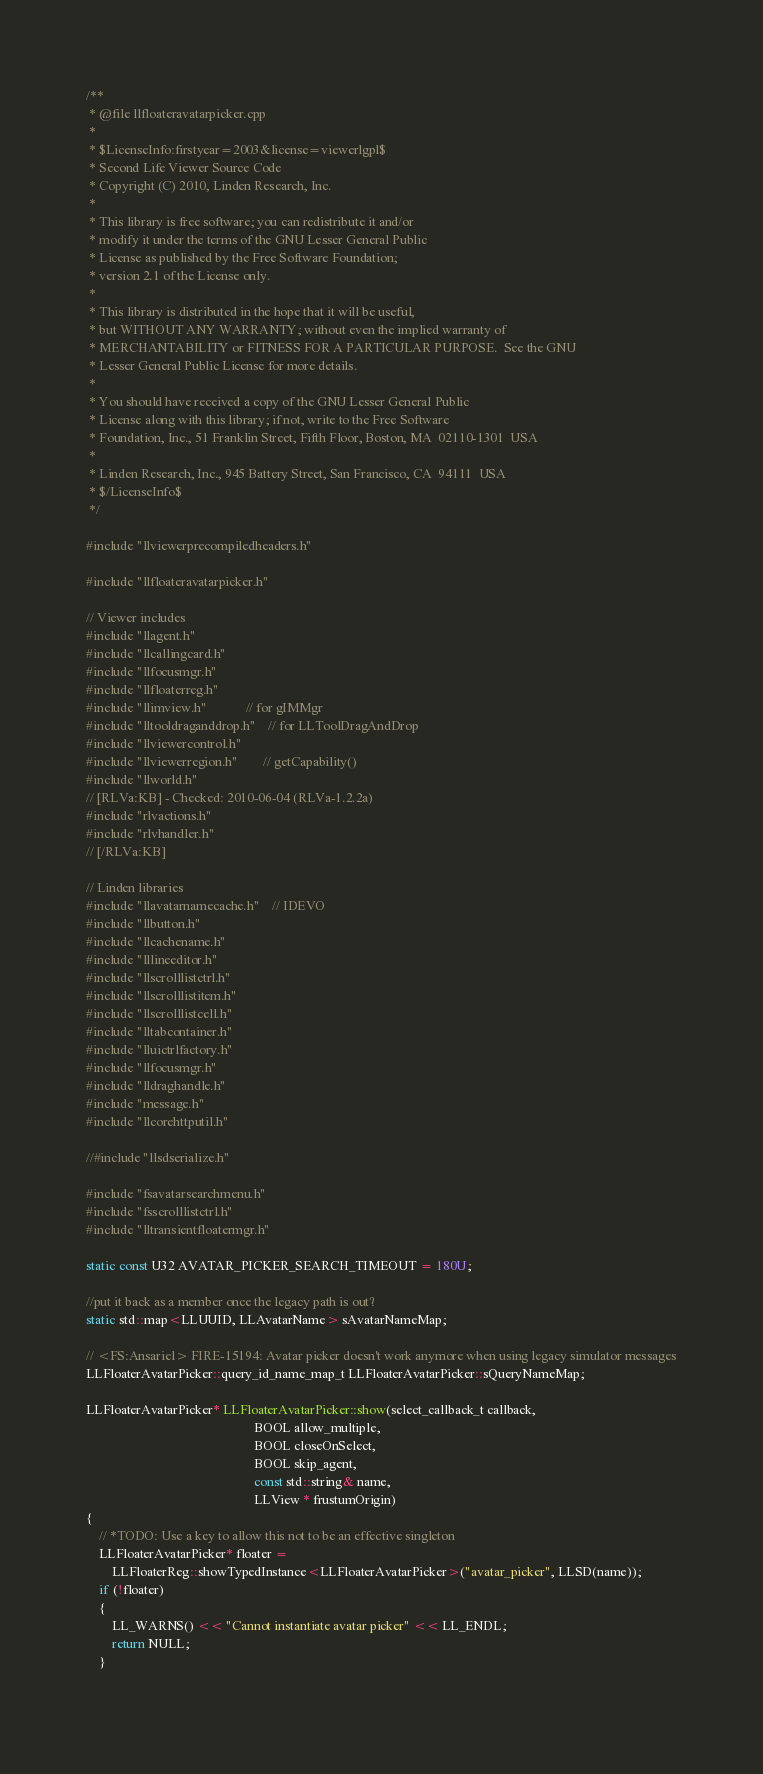Convert code to text. <code><loc_0><loc_0><loc_500><loc_500><_C++_>/** 
 * @file llfloateravatarpicker.cpp
 *
 * $LicenseInfo:firstyear=2003&license=viewerlgpl$
 * Second Life Viewer Source Code
 * Copyright (C) 2010, Linden Research, Inc.
 * 
 * This library is free software; you can redistribute it and/or
 * modify it under the terms of the GNU Lesser General Public
 * License as published by the Free Software Foundation;
 * version 2.1 of the License only.
 * 
 * This library is distributed in the hope that it will be useful,
 * but WITHOUT ANY WARRANTY; without even the implied warranty of
 * MERCHANTABILITY or FITNESS FOR A PARTICULAR PURPOSE.  See the GNU
 * Lesser General Public License for more details.
 * 
 * You should have received a copy of the GNU Lesser General Public
 * License along with this library; if not, write to the Free Software
 * Foundation, Inc., 51 Franklin Street, Fifth Floor, Boston, MA  02110-1301  USA
 * 
 * Linden Research, Inc., 945 Battery Street, San Francisco, CA  94111  USA
 * $/LicenseInfo$
 */

#include "llviewerprecompiledheaders.h"

#include "llfloateravatarpicker.h"

// Viewer includes
#include "llagent.h"
#include "llcallingcard.h"
#include "llfocusmgr.h"
#include "llfloaterreg.h"
#include "llimview.h"			// for gIMMgr
#include "lltooldraganddrop.h"	// for LLToolDragAndDrop
#include "llviewercontrol.h"
#include "llviewerregion.h"		// getCapability()
#include "llworld.h"
// [RLVa:KB] - Checked: 2010-06-04 (RLVa-1.2.2a)
#include "rlvactions.h"
#include "rlvhandler.h"
// [/RLVa:KB]

// Linden libraries
#include "llavatarnamecache.h"	// IDEVO
#include "llbutton.h"
#include "llcachename.h"
#include "lllineeditor.h"
#include "llscrolllistctrl.h"
#include "llscrolllistitem.h"
#include "llscrolllistcell.h"
#include "lltabcontainer.h"
#include "lluictrlfactory.h"
#include "llfocusmgr.h"
#include "lldraghandle.h"
#include "message.h"
#include "llcorehttputil.h"

//#include "llsdserialize.h"

#include "fsavatarsearchmenu.h"
#include "fsscrolllistctrl.h"
#include "lltransientfloatermgr.h"

static const U32 AVATAR_PICKER_SEARCH_TIMEOUT = 180U;

//put it back as a member once the legacy path is out?
static std::map<LLUUID, LLAvatarName> sAvatarNameMap;

// <FS:Ansariel> FIRE-15194: Avatar picker doesn't work anymore when using legacy simulator messages
LLFloaterAvatarPicker::query_id_name_map_t LLFloaterAvatarPicker::sQueryNameMap;

LLFloaterAvatarPicker* LLFloaterAvatarPicker::show(select_callback_t callback,
												   BOOL allow_multiple,
												   BOOL closeOnSelect,
												   BOOL skip_agent,
                                                   const std::string& name,
                                                   LLView * frustumOrigin)
{
	// *TODO: Use a key to allow this not to be an effective singleton
	LLFloaterAvatarPicker* floater = 
		LLFloaterReg::showTypedInstance<LLFloaterAvatarPicker>("avatar_picker", LLSD(name));
	if (!floater)
	{
		LL_WARNS() << "Cannot instantiate avatar picker" << LL_ENDL;
		return NULL;
	}
	</code> 